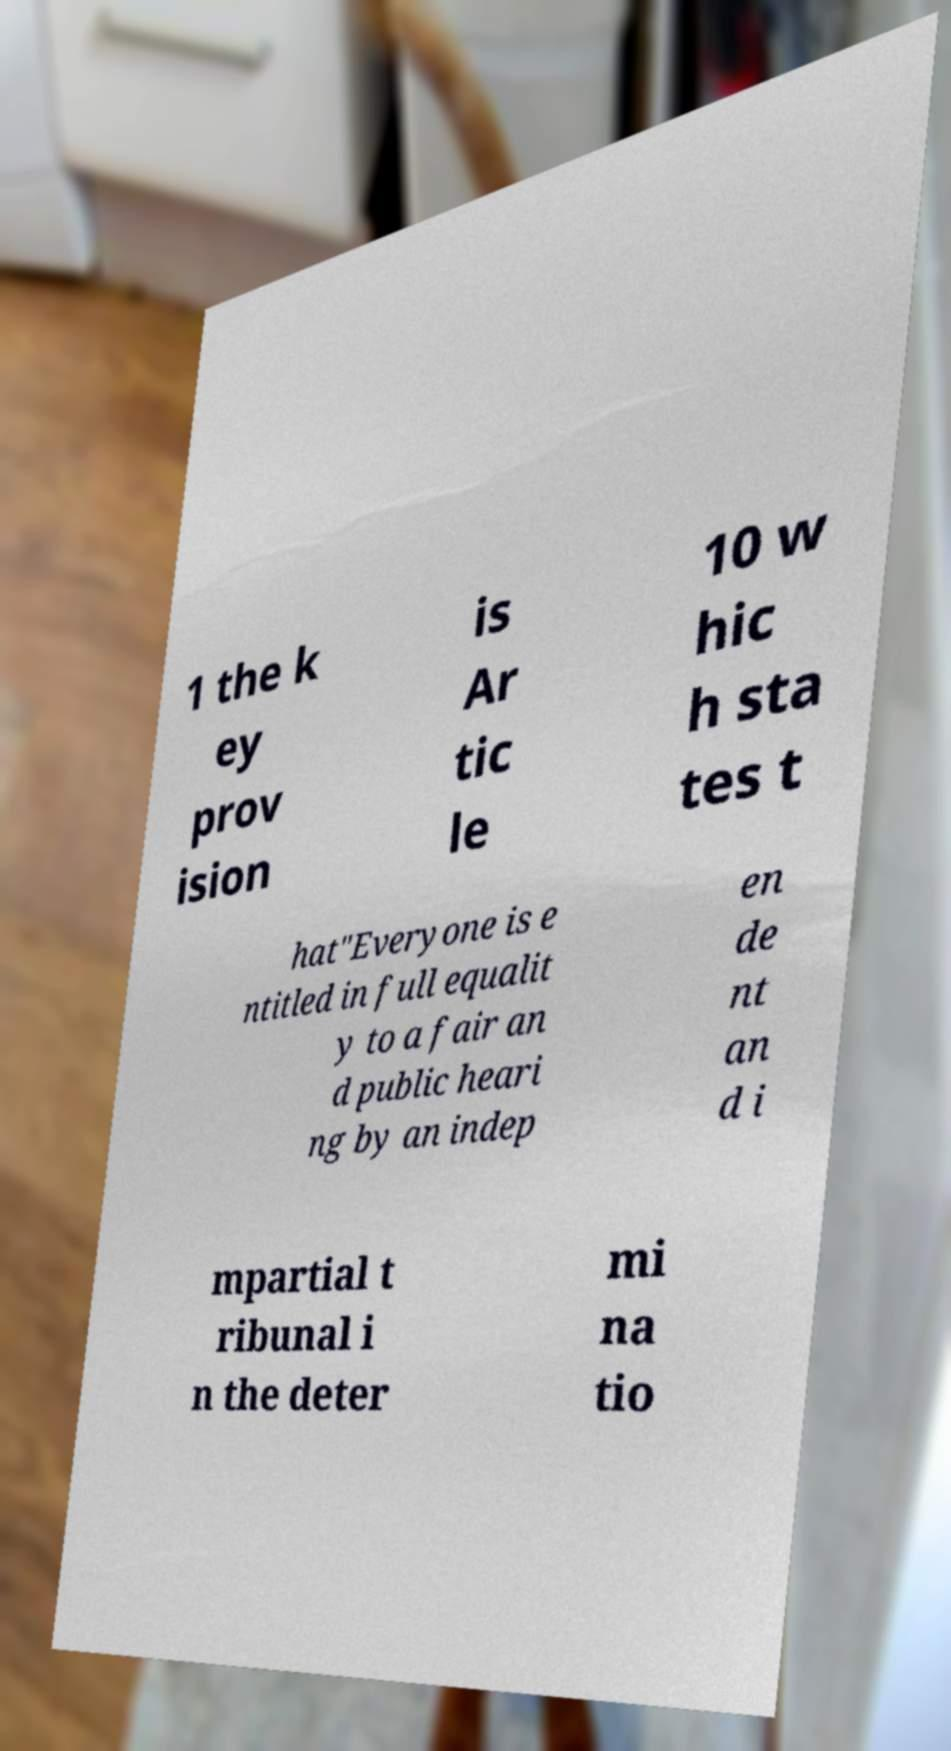I need the written content from this picture converted into text. Can you do that? 1 the k ey prov ision is Ar tic le 10 w hic h sta tes t hat"Everyone is e ntitled in full equalit y to a fair an d public heari ng by an indep en de nt an d i mpartial t ribunal i n the deter mi na tio 